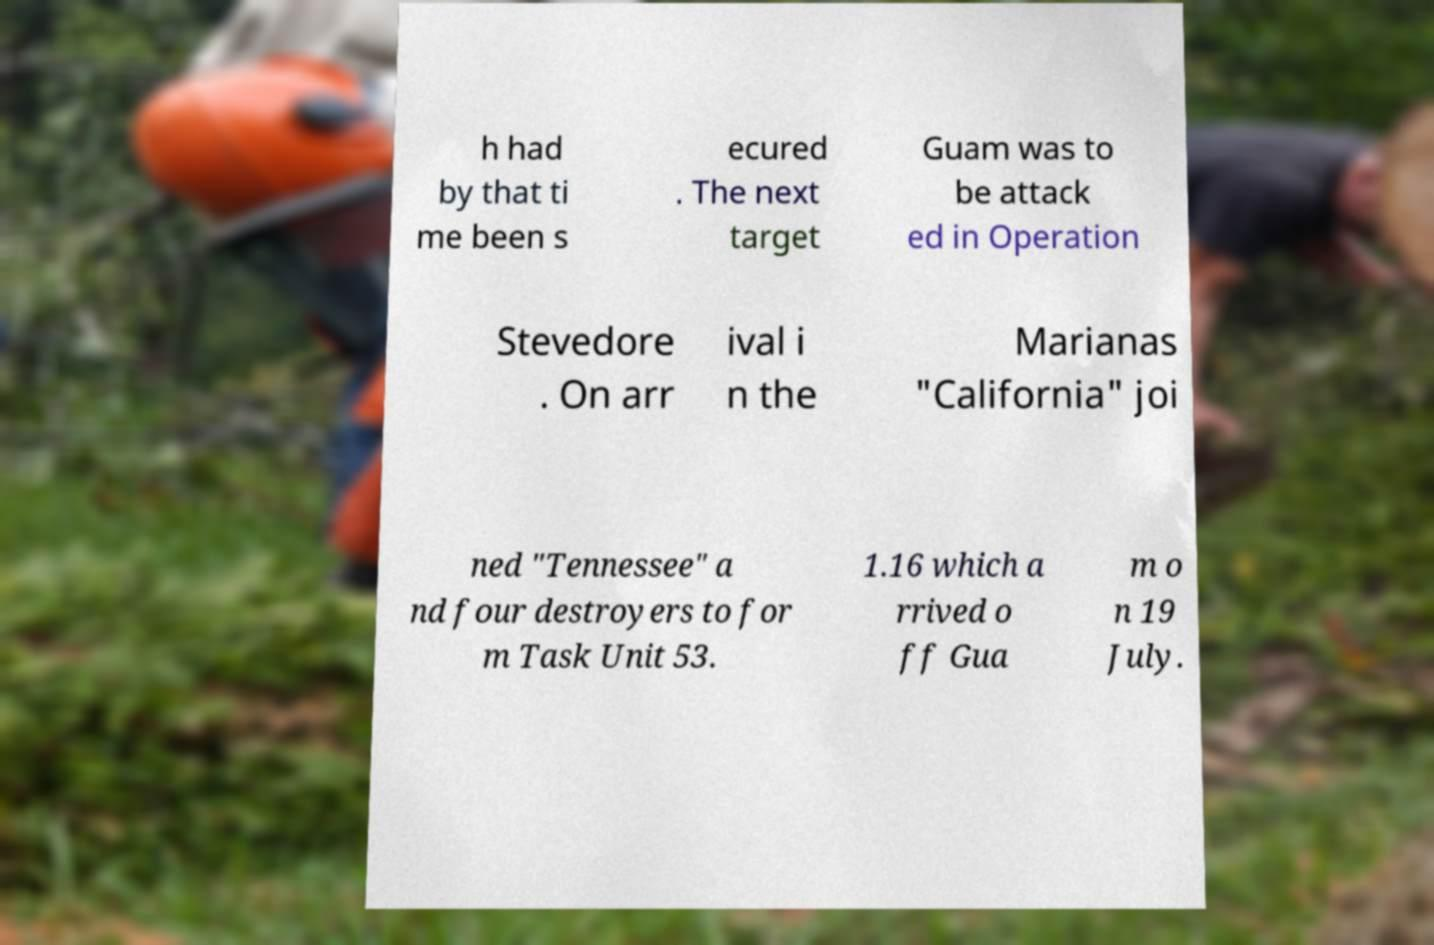There's text embedded in this image that I need extracted. Can you transcribe it verbatim? h had by that ti me been s ecured . The next target Guam was to be attack ed in Operation Stevedore . On arr ival i n the Marianas "California" joi ned "Tennessee" a nd four destroyers to for m Task Unit 53. 1.16 which a rrived o ff Gua m o n 19 July. 